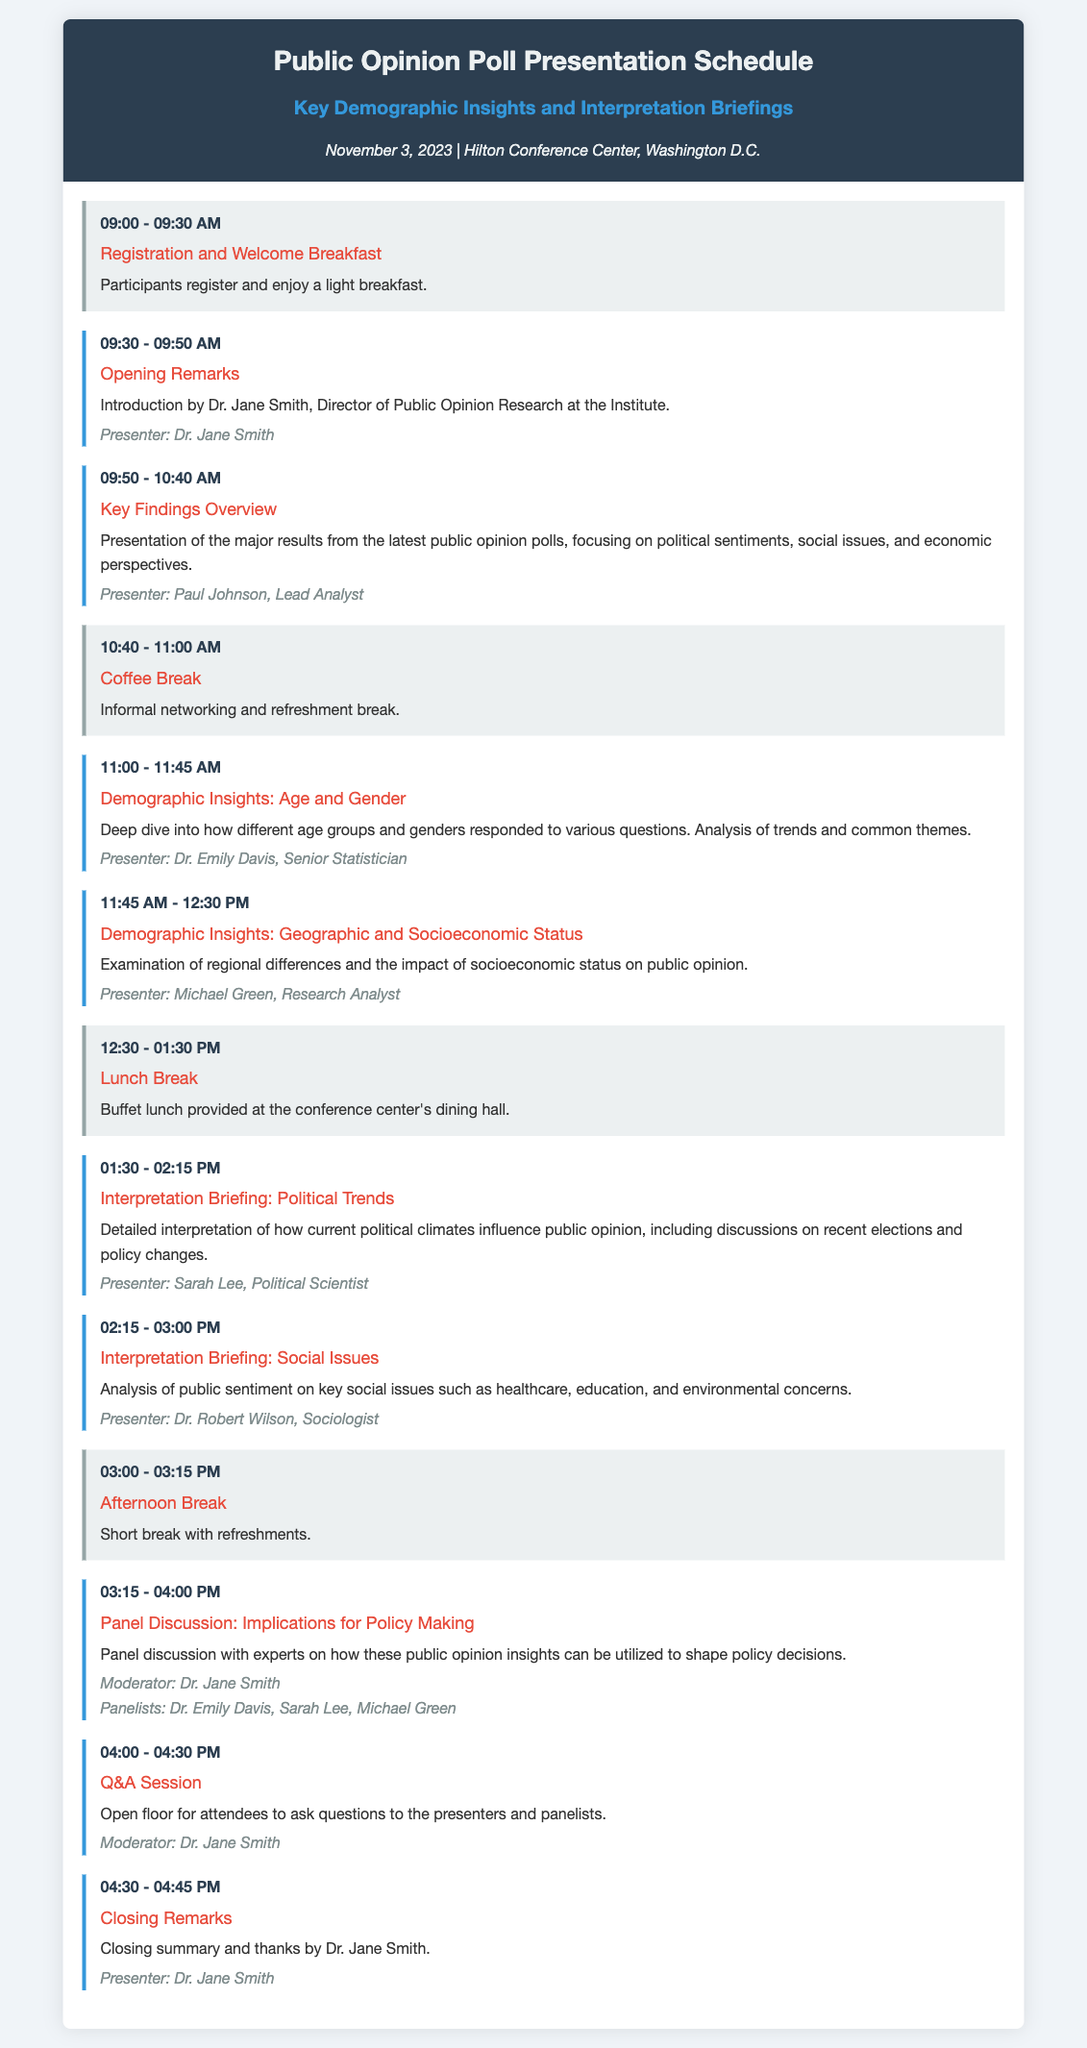What is the date of the event? The date of the event is specified in the document header as November 3, 2023.
Answer: November 3, 2023 Who is the presenter for the "Key Findings Overview" session? The document lists Paul Johnson as the presenter for this session.
Answer: Paul Johnson What time does the "Demographic Insights: Age and Gender" session start? The session timings are listed under each session; it starts at 11:00 AM.
Answer: 11:00 AM What type of meal is provided during the lunch break? The document specifies that a buffet lunch is provided during the lunch break.
Answer: Buffet lunch Which session discusses "Interpretation Briefing: Social Issues"? The document indicates that Dr. Robert Wilson is the presenter for this session focused on social issues.
Answer: Dr. Robert Wilson How long is the "Coffee Break"? The "Coffee Break" is mentioned in the schedule as lasting for 20 minutes.
Answer: 20 minutes What is the role of Dr. Jane Smith during the event? Dr. Jane Smith is identified as the Director of Public Opinion Research and serves as a moderator and presenter.
Answer: Moderator and presenter How many panelists are involved in the "Panel Discussion: Implications for Policy Making"? The document lists three panelists participating in this discussion alongside the moderator.
Answer: Three panelists What color primarily represents the header background? The document specifies the header background color as a shade that can be identified as dark blue.
Answer: Dark blue 